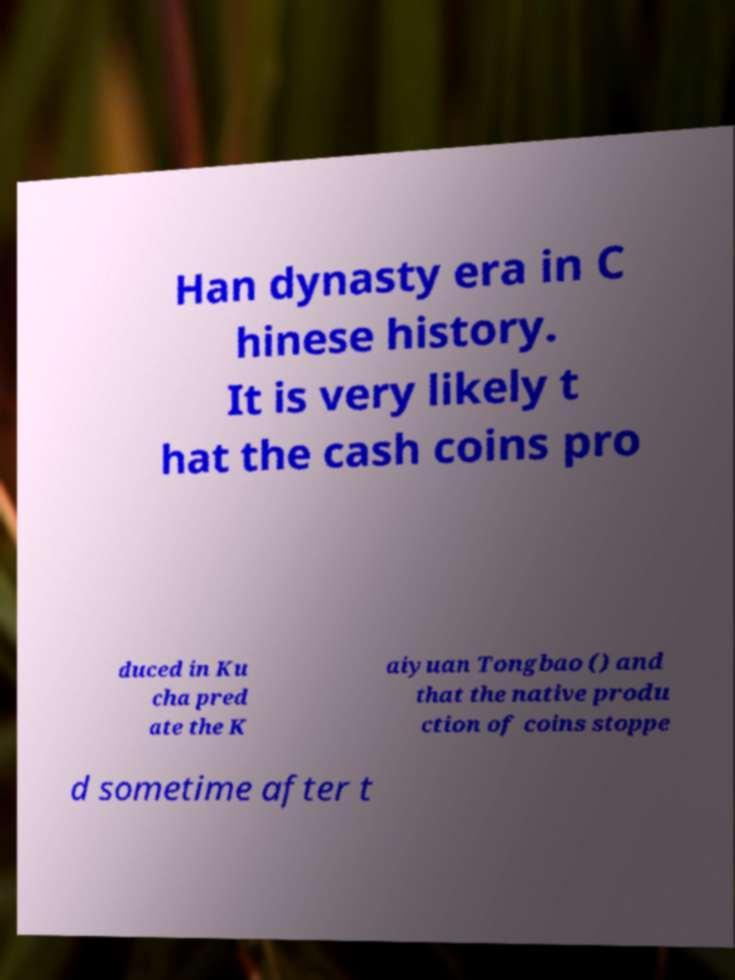Could you extract and type out the text from this image? Han dynasty era in C hinese history. It is very likely t hat the cash coins pro duced in Ku cha pred ate the K aiyuan Tongbao () and that the native produ ction of coins stoppe d sometime after t 